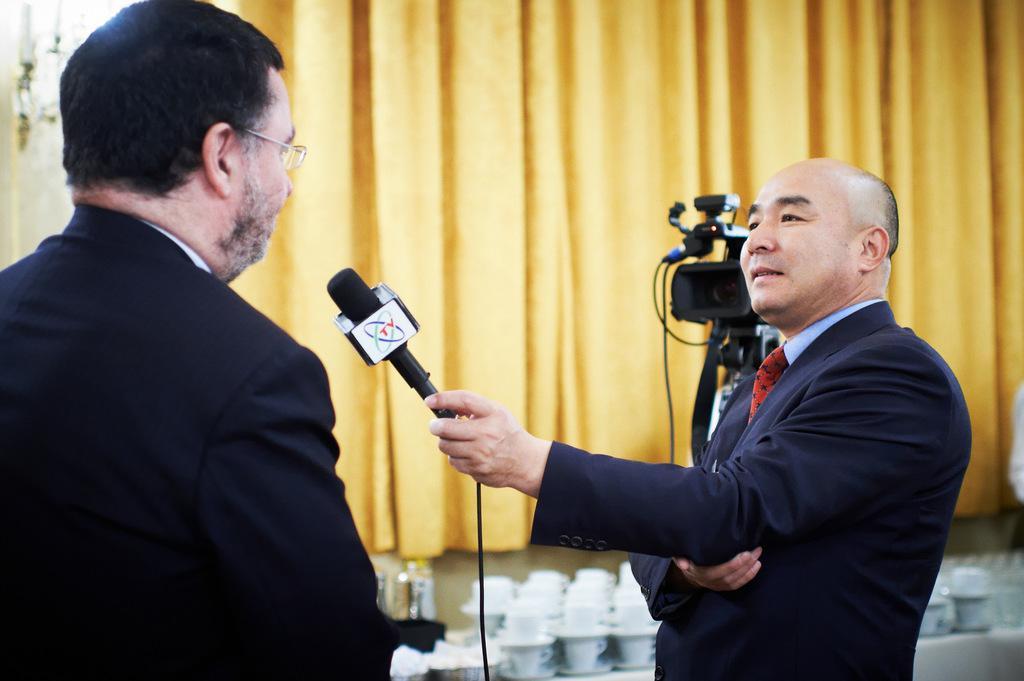Can you describe this image briefly? In this picture there is a man holding a mic in his hand and asking question to another man. In the background there is a video camera. There are some cups placed on the table. We can observe yellow color curtain here. 